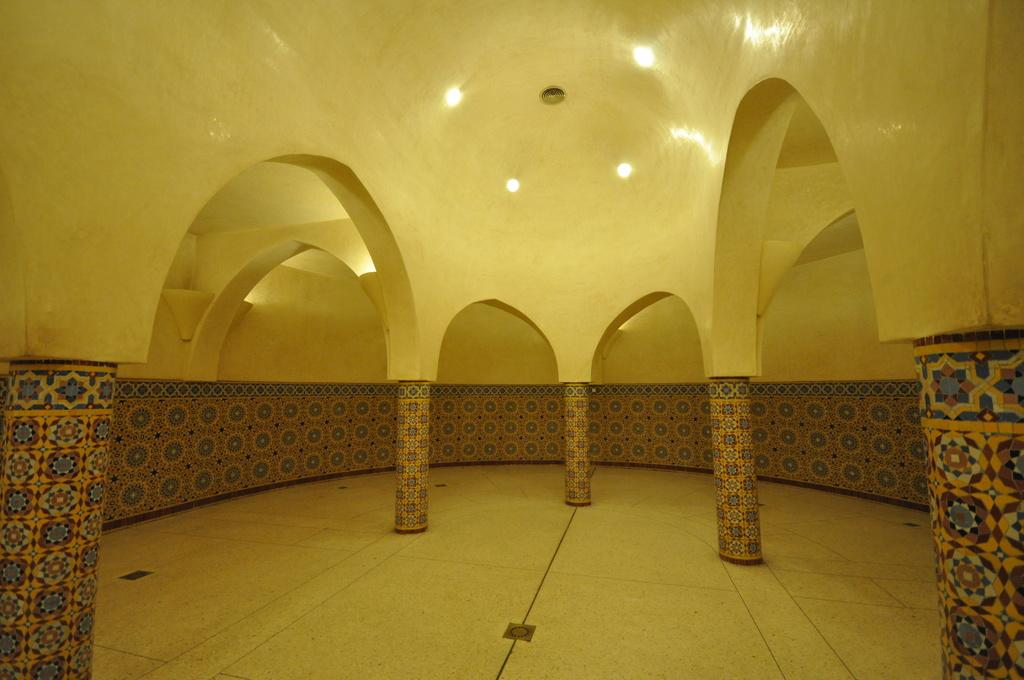What type of location is depicted in the image? The image is an inside picture of a building. What architectural features can be seen in the image? There are pillars and a wall visible in the image. What part of the building is shown at the bottom of the image? The image shows a floor at the bottom. What can be seen at the top of the image? There are lights visible at the top of the image. Where are the toys being stored in the image? There are no toys present in the image. What is the duration of the recess in the image? There is no recess depicted in the image. 